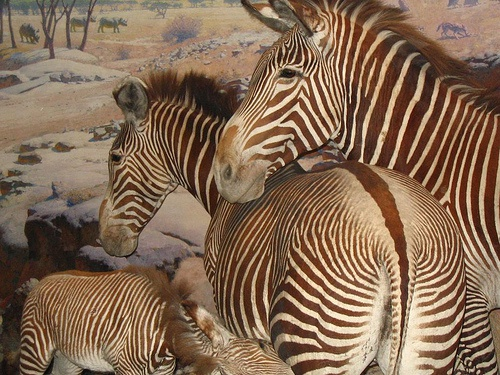Describe the objects in this image and their specific colors. I can see zebra in purple, maroon, black, and tan tones, zebra in purple, maroon, and tan tones, and zebra in purple, maroon, gray, and tan tones in this image. 